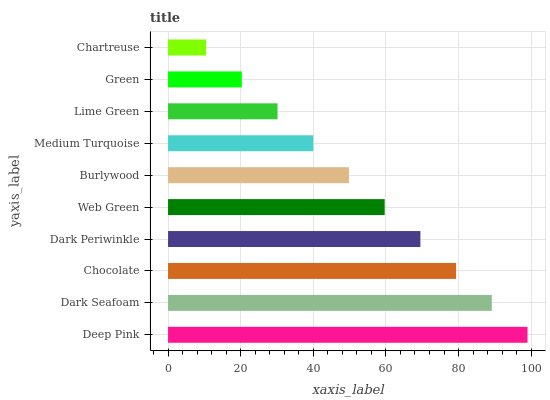Is Chartreuse the minimum?
Answer yes or no. Yes. Is Deep Pink the maximum?
Answer yes or no. Yes. Is Dark Seafoam the minimum?
Answer yes or no. No. Is Dark Seafoam the maximum?
Answer yes or no. No. Is Deep Pink greater than Dark Seafoam?
Answer yes or no. Yes. Is Dark Seafoam less than Deep Pink?
Answer yes or no. Yes. Is Dark Seafoam greater than Deep Pink?
Answer yes or no. No. Is Deep Pink less than Dark Seafoam?
Answer yes or no. No. Is Web Green the high median?
Answer yes or no. Yes. Is Burlywood the low median?
Answer yes or no. Yes. Is Burlywood the high median?
Answer yes or no. No. Is Deep Pink the low median?
Answer yes or no. No. 